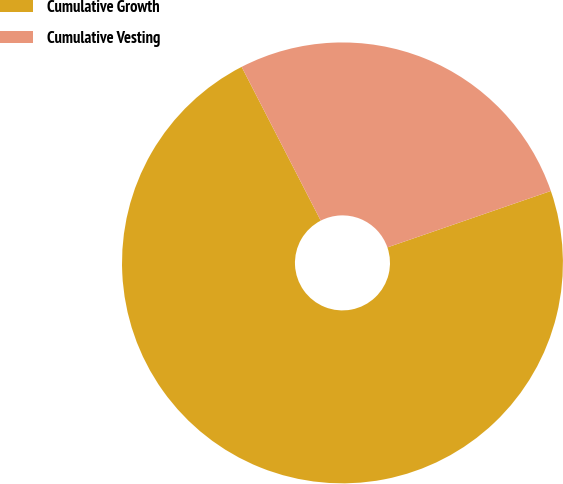Convert chart. <chart><loc_0><loc_0><loc_500><loc_500><pie_chart><fcel>Cumulative Growth<fcel>Cumulative Vesting<nl><fcel>72.73%<fcel>27.27%<nl></chart> 